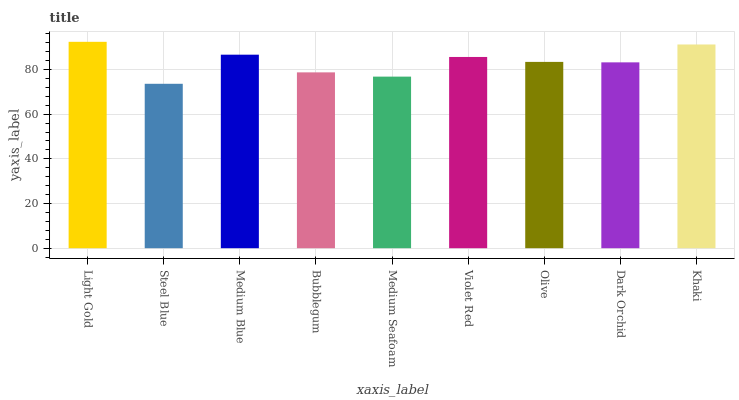Is Steel Blue the minimum?
Answer yes or no. Yes. Is Light Gold the maximum?
Answer yes or no. Yes. Is Medium Blue the minimum?
Answer yes or no. No. Is Medium Blue the maximum?
Answer yes or no. No. Is Medium Blue greater than Steel Blue?
Answer yes or no. Yes. Is Steel Blue less than Medium Blue?
Answer yes or no. Yes. Is Steel Blue greater than Medium Blue?
Answer yes or no. No. Is Medium Blue less than Steel Blue?
Answer yes or no. No. Is Olive the high median?
Answer yes or no. Yes. Is Olive the low median?
Answer yes or no. Yes. Is Medium Blue the high median?
Answer yes or no. No. Is Medium Blue the low median?
Answer yes or no. No. 